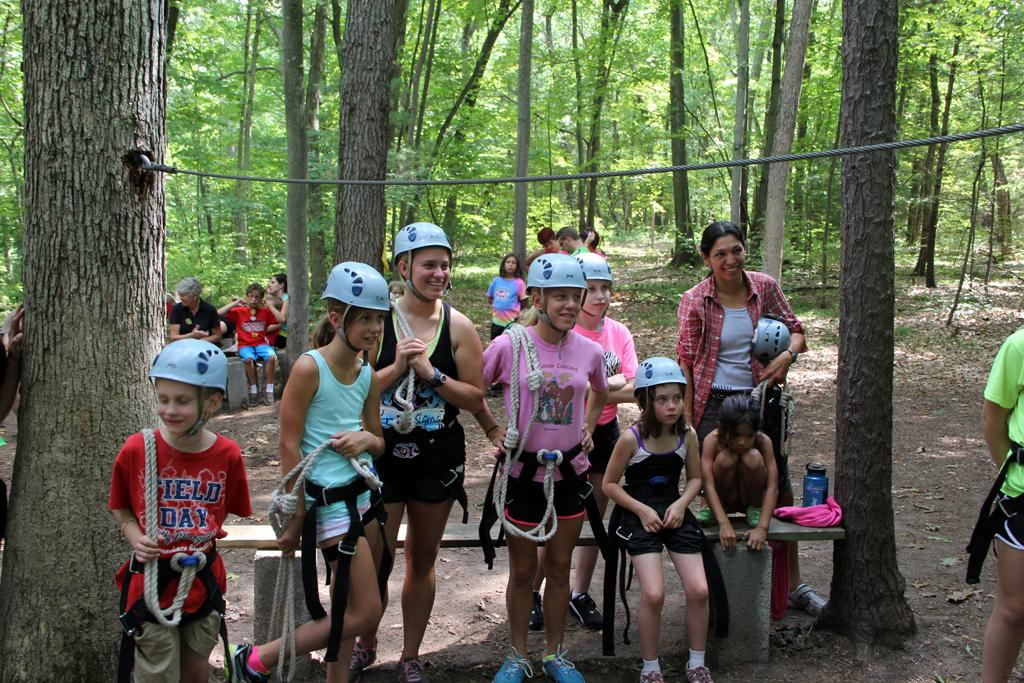What can be seen in the background of the image? There are trees and people in the background of the image. What are the people in the background doing? Some people are standing, while others are sitting in the background. What is present on the platform in the image? There is a bottle and a pink cloth on the platform. What type of protective gear are some people wearing in the image? People wearing helmets are visible in the image. What type of party is happening in the image? There is no party present in the image. What is the base made of in the image? There is no base present in the image. 